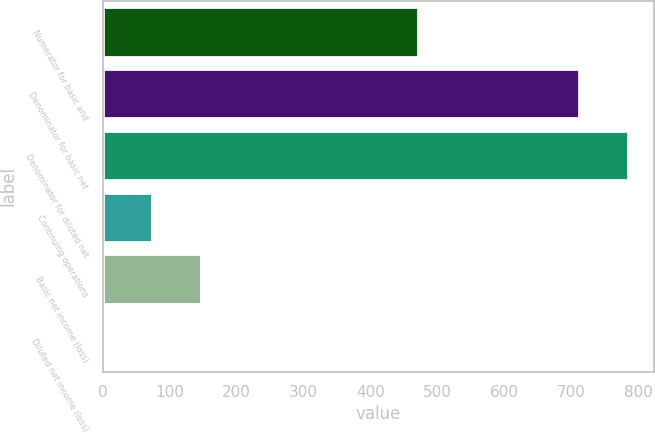Convert chart. <chart><loc_0><loc_0><loc_500><loc_500><bar_chart><fcel>Numerator for basic and<fcel>Denominator for basic net<fcel>Denominator for diluted net<fcel>Continuing operations<fcel>Basic net income (loss)<fcel>Diluted net income (loss)<nl><fcel>471<fcel>711<fcel>784.24<fcel>73.88<fcel>147.12<fcel>0.64<nl></chart> 